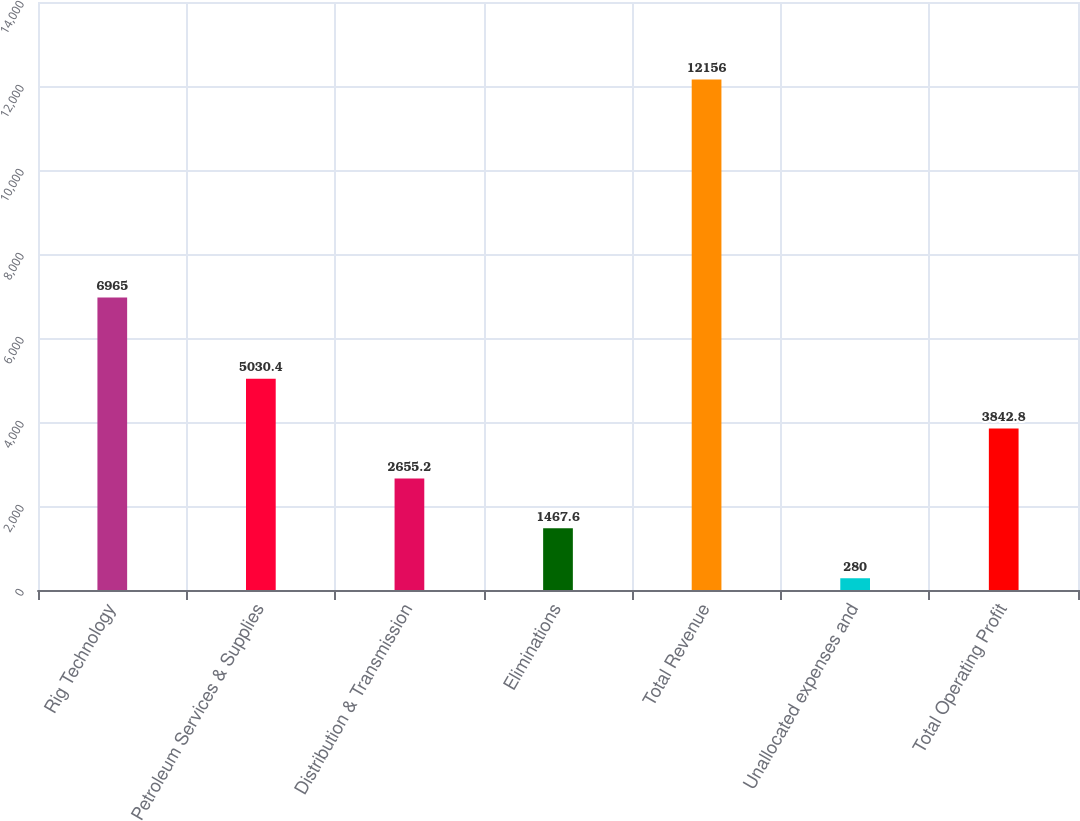<chart> <loc_0><loc_0><loc_500><loc_500><bar_chart><fcel>Rig Technology<fcel>Petroleum Services & Supplies<fcel>Distribution & Transmission<fcel>Eliminations<fcel>Total Revenue<fcel>Unallocated expenses and<fcel>Total Operating Profit<nl><fcel>6965<fcel>5030.4<fcel>2655.2<fcel>1467.6<fcel>12156<fcel>280<fcel>3842.8<nl></chart> 